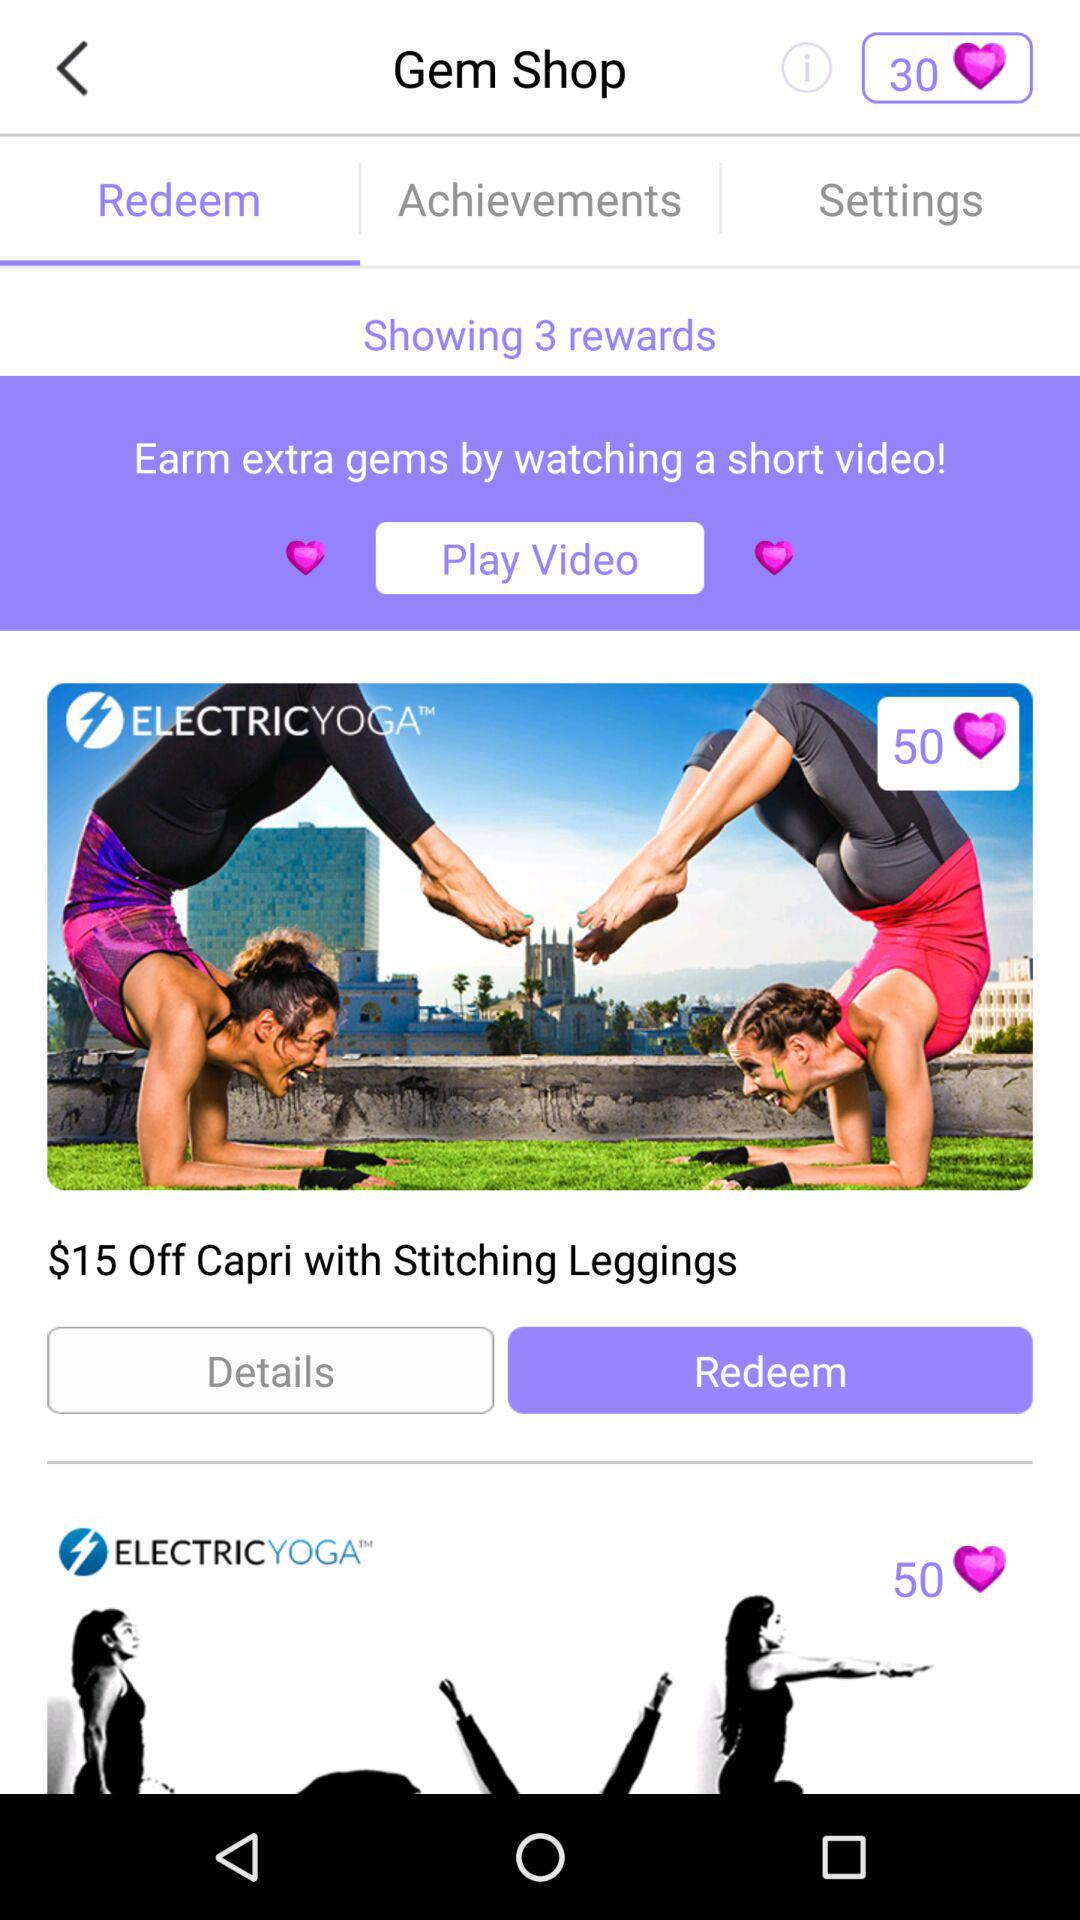What is the discount on "Capri with Stitching Leggings"? The discount is $15. 